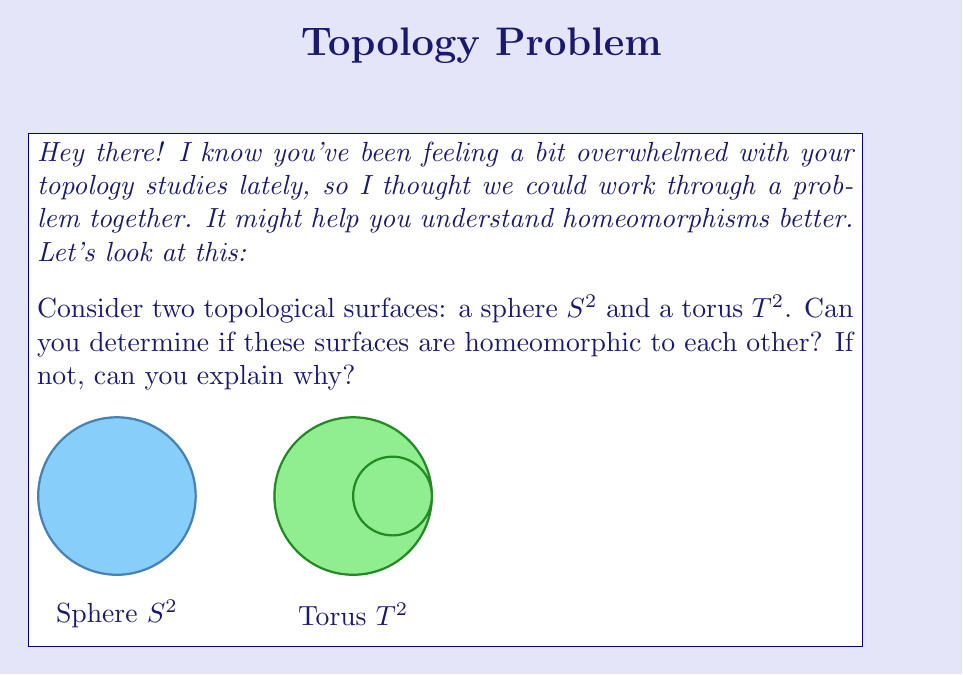Can you answer this question? Let's approach this step-by-step:

1) First, recall that two topological spaces are homeomorphic if there exists a continuous bijective function between them with a continuous inverse.

2) To determine if the sphere $S^2$ and torus $T^2$ are homeomorphic, we need to consider their topological properties.

3) One important topological invariant is the Euler characteristic $\chi$. For any surface, it's calculated as:

   $$\chi = V - E + F$$

   where $V$ is the number of vertices, $E$ is the number of edges, and $F$ is the number of faces in any triangulation of the surface.

4) For a sphere $S^2$:
   - Consider a tetrahedron (the simplest triangulation of a sphere)
   - $V = 4$, $E = 6$, $F = 4$
   - $\chi(S^2) = 4 - 6 + 4 = 2$

5) For a torus $T^2$:
   - Consider a standard triangulation of a torus
   - $\chi(T^2) = 0$ (this can be proven, but the derivation is beyond the scope of this problem)

6) Since the Euler characteristic is a topological invariant, if two surfaces are homeomorphic, they must have the same Euler characteristic.

7) We've shown that $\chi(S^2) \neq \chi(T^2)$, therefore $S^2$ and $T^2$ cannot be homeomorphic.

8) Intuitively, this makes sense because a sphere has no "holes," while a torus has one "hole." You can't continuously deform a sphere into a torus without cutting or gluing.
Answer: $S^2$ and $T^2$ are not homeomorphic because $\chi(S^2) = 2 \neq 0 = \chi(T^2)$. 